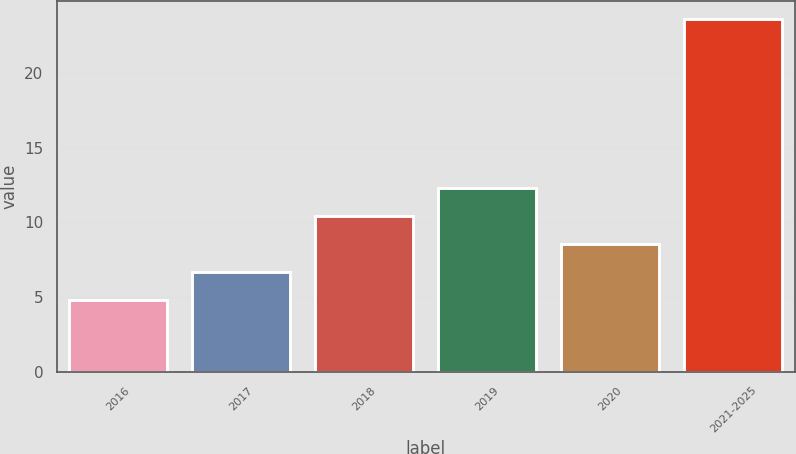<chart> <loc_0><loc_0><loc_500><loc_500><bar_chart><fcel>2016<fcel>2017<fcel>2018<fcel>2019<fcel>2020<fcel>2021-2025<nl><fcel>4.8<fcel>6.68<fcel>10.44<fcel>12.32<fcel>8.56<fcel>23.6<nl></chart> 